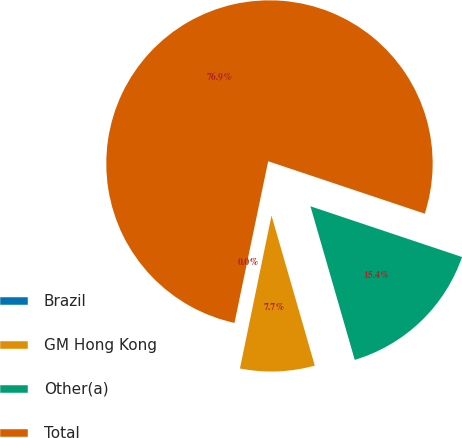<chart> <loc_0><loc_0><loc_500><loc_500><pie_chart><fcel>Brazil<fcel>GM Hong Kong<fcel>Other(a)<fcel>Total<nl><fcel>0.03%<fcel>7.71%<fcel>15.39%<fcel>76.87%<nl></chart> 